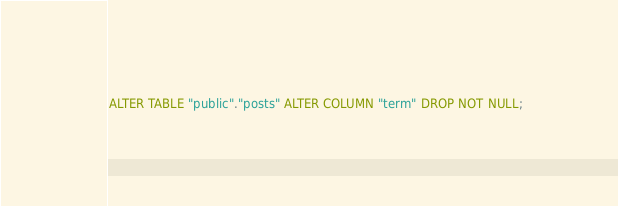Convert code to text. <code><loc_0><loc_0><loc_500><loc_500><_SQL_>
ALTER TABLE "public"."posts" ALTER COLUMN "term" DROP NOT NULL;</code> 